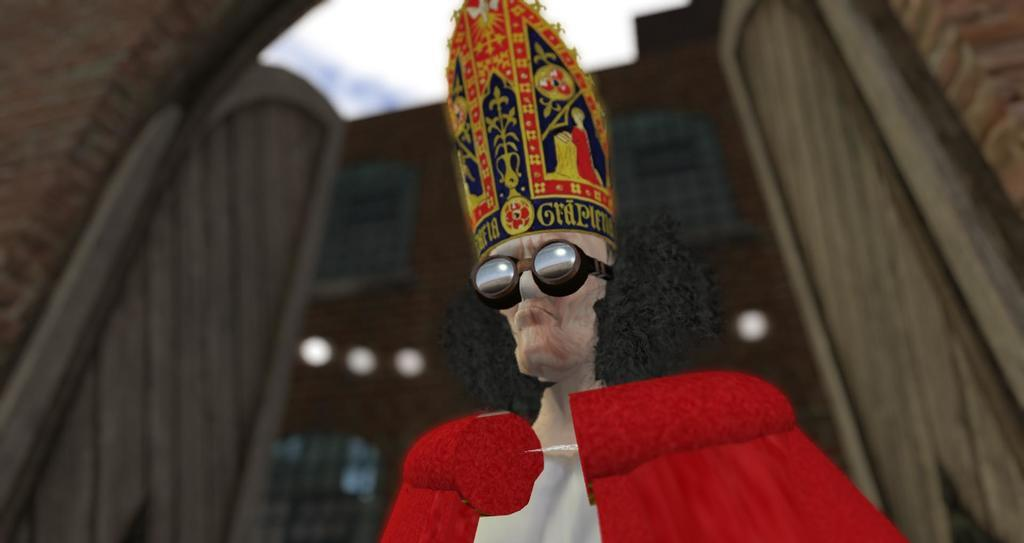What type of visual content is depicted in the image? The image is an animation. Can you describe the person in the animation? The person is wearing a cap and glasses. What can be seen in the background of the animation? There are buildings in the background of the animation. What is there is a judge in the animation, what is the judge's name? There is no judge present in the animation, so it is not possible to determine the judge's name. 